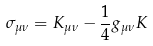Convert formula to latex. <formula><loc_0><loc_0><loc_500><loc_500>\sigma _ { \mu \nu } = K _ { \mu \nu } - \frac { 1 } { 4 } g _ { \mu \nu } K</formula> 